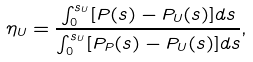Convert formula to latex. <formula><loc_0><loc_0><loc_500><loc_500>\eta _ { U } = \frac { \int _ { 0 } ^ { s _ { U } } [ P ( s ) - P _ { U } ( s ) ] d s } { \int _ { 0 } ^ { s _ { U } } [ P _ { P } ( s ) - P _ { U } ( s ) ] d s } ,</formula> 